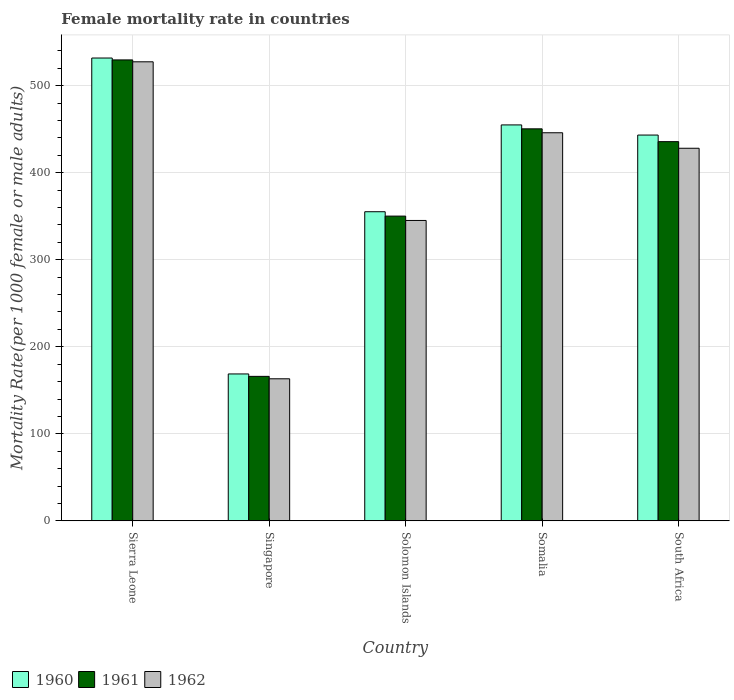How many bars are there on the 1st tick from the right?
Ensure brevity in your answer.  3. What is the label of the 3rd group of bars from the left?
Your answer should be compact. Solomon Islands. What is the female mortality rate in 1962 in Sierra Leone?
Make the answer very short. 527.53. Across all countries, what is the maximum female mortality rate in 1961?
Provide a short and direct response. 529.71. Across all countries, what is the minimum female mortality rate in 1961?
Offer a very short reply. 166.03. In which country was the female mortality rate in 1960 maximum?
Your response must be concise. Sierra Leone. In which country was the female mortality rate in 1961 minimum?
Provide a succinct answer. Singapore. What is the total female mortality rate in 1962 in the graph?
Keep it short and to the point. 1910.15. What is the difference between the female mortality rate in 1961 in Somalia and that in South Africa?
Provide a succinct answer. 14.73. What is the difference between the female mortality rate in 1961 in Sierra Leone and the female mortality rate in 1962 in Singapore?
Keep it short and to the point. 366.46. What is the average female mortality rate in 1962 per country?
Offer a terse response. 382.03. What is the difference between the female mortality rate of/in 1960 and female mortality rate of/in 1961 in Somalia?
Give a very brief answer. 4.5. What is the ratio of the female mortality rate in 1961 in Sierra Leone to that in Somalia?
Ensure brevity in your answer.  1.18. Is the difference between the female mortality rate in 1960 in Sierra Leone and Singapore greater than the difference between the female mortality rate in 1961 in Sierra Leone and Singapore?
Offer a very short reply. No. What is the difference between the highest and the second highest female mortality rate in 1962?
Offer a very short reply. -17.81. What is the difference between the highest and the lowest female mortality rate in 1960?
Make the answer very short. 363.07. Is the sum of the female mortality rate in 1962 in Solomon Islands and Somalia greater than the maximum female mortality rate in 1960 across all countries?
Provide a short and direct response. Yes. Is it the case that in every country, the sum of the female mortality rate in 1962 and female mortality rate in 1960 is greater than the female mortality rate in 1961?
Give a very brief answer. Yes. How many countries are there in the graph?
Make the answer very short. 5. What is the difference between two consecutive major ticks on the Y-axis?
Your answer should be compact. 100. Are the values on the major ticks of Y-axis written in scientific E-notation?
Keep it short and to the point. No. Does the graph contain any zero values?
Keep it short and to the point. No. Does the graph contain grids?
Keep it short and to the point. Yes. What is the title of the graph?
Offer a very short reply. Female mortality rate in countries. Does "1994" appear as one of the legend labels in the graph?
Your answer should be very brief. No. What is the label or title of the Y-axis?
Offer a terse response. Mortality Rate(per 1000 female or male adults). What is the Mortality Rate(per 1000 female or male adults) of 1960 in Sierra Leone?
Your answer should be very brief. 531.89. What is the Mortality Rate(per 1000 female or male adults) in 1961 in Sierra Leone?
Your response must be concise. 529.71. What is the Mortality Rate(per 1000 female or male adults) of 1962 in Sierra Leone?
Offer a terse response. 527.53. What is the Mortality Rate(per 1000 female or male adults) in 1960 in Singapore?
Keep it short and to the point. 168.82. What is the Mortality Rate(per 1000 female or male adults) of 1961 in Singapore?
Provide a succinct answer. 166.03. What is the Mortality Rate(per 1000 female or male adults) of 1962 in Singapore?
Make the answer very short. 163.25. What is the Mortality Rate(per 1000 female or male adults) of 1960 in Solomon Islands?
Provide a succinct answer. 355.23. What is the Mortality Rate(per 1000 female or male adults) in 1961 in Solomon Islands?
Your response must be concise. 350.21. What is the Mortality Rate(per 1000 female or male adults) of 1962 in Solomon Islands?
Offer a very short reply. 345.19. What is the Mortality Rate(per 1000 female or male adults) of 1960 in Somalia?
Offer a terse response. 455. What is the Mortality Rate(per 1000 female or male adults) of 1961 in Somalia?
Ensure brevity in your answer.  450.5. What is the Mortality Rate(per 1000 female or male adults) in 1962 in Somalia?
Your answer should be compact. 446. What is the Mortality Rate(per 1000 female or male adults) of 1960 in South Africa?
Provide a succinct answer. 443.35. What is the Mortality Rate(per 1000 female or male adults) in 1961 in South Africa?
Keep it short and to the point. 435.77. What is the Mortality Rate(per 1000 female or male adults) of 1962 in South Africa?
Provide a succinct answer. 428.18. Across all countries, what is the maximum Mortality Rate(per 1000 female or male adults) in 1960?
Give a very brief answer. 531.89. Across all countries, what is the maximum Mortality Rate(per 1000 female or male adults) in 1961?
Your response must be concise. 529.71. Across all countries, what is the maximum Mortality Rate(per 1000 female or male adults) in 1962?
Offer a very short reply. 527.53. Across all countries, what is the minimum Mortality Rate(per 1000 female or male adults) in 1960?
Give a very brief answer. 168.82. Across all countries, what is the minimum Mortality Rate(per 1000 female or male adults) in 1961?
Offer a terse response. 166.03. Across all countries, what is the minimum Mortality Rate(per 1000 female or male adults) in 1962?
Offer a terse response. 163.25. What is the total Mortality Rate(per 1000 female or male adults) of 1960 in the graph?
Your answer should be very brief. 1954.28. What is the total Mortality Rate(per 1000 female or male adults) in 1961 in the graph?
Your answer should be compact. 1932.21. What is the total Mortality Rate(per 1000 female or male adults) of 1962 in the graph?
Give a very brief answer. 1910.15. What is the difference between the Mortality Rate(per 1000 female or male adults) in 1960 in Sierra Leone and that in Singapore?
Provide a succinct answer. 363.07. What is the difference between the Mortality Rate(per 1000 female or male adults) in 1961 in Sierra Leone and that in Singapore?
Your response must be concise. 363.68. What is the difference between the Mortality Rate(per 1000 female or male adults) in 1962 in Sierra Leone and that in Singapore?
Your response must be concise. 364.29. What is the difference between the Mortality Rate(per 1000 female or male adults) in 1960 in Sierra Leone and that in Solomon Islands?
Make the answer very short. 176.66. What is the difference between the Mortality Rate(per 1000 female or male adults) in 1961 in Sierra Leone and that in Solomon Islands?
Ensure brevity in your answer.  179.5. What is the difference between the Mortality Rate(per 1000 female or male adults) of 1962 in Sierra Leone and that in Solomon Islands?
Offer a terse response. 182.34. What is the difference between the Mortality Rate(per 1000 female or male adults) in 1960 in Sierra Leone and that in Somalia?
Give a very brief answer. 76.89. What is the difference between the Mortality Rate(per 1000 female or male adults) of 1961 in Sierra Leone and that in Somalia?
Provide a short and direct response. 79.21. What is the difference between the Mortality Rate(per 1000 female or male adults) of 1962 in Sierra Leone and that in Somalia?
Give a very brief answer. 81.54. What is the difference between the Mortality Rate(per 1000 female or male adults) in 1960 in Sierra Leone and that in South Africa?
Keep it short and to the point. 88.54. What is the difference between the Mortality Rate(per 1000 female or male adults) of 1961 in Sierra Leone and that in South Africa?
Keep it short and to the point. 93.94. What is the difference between the Mortality Rate(per 1000 female or male adults) of 1962 in Sierra Leone and that in South Africa?
Provide a succinct answer. 99.35. What is the difference between the Mortality Rate(per 1000 female or male adults) of 1960 in Singapore and that in Solomon Islands?
Offer a very short reply. -186.41. What is the difference between the Mortality Rate(per 1000 female or male adults) of 1961 in Singapore and that in Solomon Islands?
Offer a terse response. -184.18. What is the difference between the Mortality Rate(per 1000 female or male adults) in 1962 in Singapore and that in Solomon Islands?
Your answer should be compact. -181.94. What is the difference between the Mortality Rate(per 1000 female or male adults) in 1960 in Singapore and that in Somalia?
Provide a succinct answer. -286.18. What is the difference between the Mortality Rate(per 1000 female or male adults) of 1961 in Singapore and that in Somalia?
Provide a succinct answer. -284.47. What is the difference between the Mortality Rate(per 1000 female or male adults) of 1962 in Singapore and that in Somalia?
Make the answer very short. -282.75. What is the difference between the Mortality Rate(per 1000 female or male adults) in 1960 in Singapore and that in South Africa?
Keep it short and to the point. -274.53. What is the difference between the Mortality Rate(per 1000 female or male adults) in 1961 in Singapore and that in South Africa?
Ensure brevity in your answer.  -269.74. What is the difference between the Mortality Rate(per 1000 female or male adults) in 1962 in Singapore and that in South Africa?
Your response must be concise. -264.94. What is the difference between the Mortality Rate(per 1000 female or male adults) of 1960 in Solomon Islands and that in Somalia?
Your answer should be compact. -99.77. What is the difference between the Mortality Rate(per 1000 female or male adults) of 1961 in Solomon Islands and that in Somalia?
Your response must be concise. -100.29. What is the difference between the Mortality Rate(per 1000 female or male adults) of 1962 in Solomon Islands and that in Somalia?
Give a very brief answer. -100.81. What is the difference between the Mortality Rate(per 1000 female or male adults) of 1960 in Solomon Islands and that in South Africa?
Offer a terse response. -88.12. What is the difference between the Mortality Rate(per 1000 female or male adults) in 1961 in Solomon Islands and that in South Africa?
Your response must be concise. -85.56. What is the difference between the Mortality Rate(per 1000 female or male adults) of 1962 in Solomon Islands and that in South Africa?
Your answer should be very brief. -82.99. What is the difference between the Mortality Rate(per 1000 female or male adults) of 1960 in Somalia and that in South Africa?
Ensure brevity in your answer.  11.65. What is the difference between the Mortality Rate(per 1000 female or male adults) of 1961 in Somalia and that in South Africa?
Give a very brief answer. 14.73. What is the difference between the Mortality Rate(per 1000 female or male adults) of 1962 in Somalia and that in South Africa?
Keep it short and to the point. 17.81. What is the difference between the Mortality Rate(per 1000 female or male adults) of 1960 in Sierra Leone and the Mortality Rate(per 1000 female or male adults) of 1961 in Singapore?
Give a very brief answer. 365.86. What is the difference between the Mortality Rate(per 1000 female or male adults) in 1960 in Sierra Leone and the Mortality Rate(per 1000 female or male adults) in 1962 in Singapore?
Provide a succinct answer. 368.64. What is the difference between the Mortality Rate(per 1000 female or male adults) in 1961 in Sierra Leone and the Mortality Rate(per 1000 female or male adults) in 1962 in Singapore?
Keep it short and to the point. 366.46. What is the difference between the Mortality Rate(per 1000 female or male adults) of 1960 in Sierra Leone and the Mortality Rate(per 1000 female or male adults) of 1961 in Solomon Islands?
Your answer should be compact. 181.68. What is the difference between the Mortality Rate(per 1000 female or male adults) of 1960 in Sierra Leone and the Mortality Rate(per 1000 female or male adults) of 1962 in Solomon Islands?
Offer a terse response. 186.7. What is the difference between the Mortality Rate(per 1000 female or male adults) of 1961 in Sierra Leone and the Mortality Rate(per 1000 female or male adults) of 1962 in Solomon Islands?
Give a very brief answer. 184.52. What is the difference between the Mortality Rate(per 1000 female or male adults) of 1960 in Sierra Leone and the Mortality Rate(per 1000 female or male adults) of 1961 in Somalia?
Your answer should be very brief. 81.39. What is the difference between the Mortality Rate(per 1000 female or male adults) of 1960 in Sierra Leone and the Mortality Rate(per 1000 female or male adults) of 1962 in Somalia?
Your response must be concise. 85.89. What is the difference between the Mortality Rate(per 1000 female or male adults) in 1961 in Sierra Leone and the Mortality Rate(per 1000 female or male adults) in 1962 in Somalia?
Keep it short and to the point. 83.71. What is the difference between the Mortality Rate(per 1000 female or male adults) in 1960 in Sierra Leone and the Mortality Rate(per 1000 female or male adults) in 1961 in South Africa?
Make the answer very short. 96.12. What is the difference between the Mortality Rate(per 1000 female or male adults) in 1960 in Sierra Leone and the Mortality Rate(per 1000 female or male adults) in 1962 in South Africa?
Your response must be concise. 103.7. What is the difference between the Mortality Rate(per 1000 female or male adults) in 1961 in Sierra Leone and the Mortality Rate(per 1000 female or male adults) in 1962 in South Africa?
Offer a terse response. 101.53. What is the difference between the Mortality Rate(per 1000 female or male adults) in 1960 in Singapore and the Mortality Rate(per 1000 female or male adults) in 1961 in Solomon Islands?
Make the answer very short. -181.39. What is the difference between the Mortality Rate(per 1000 female or male adults) in 1960 in Singapore and the Mortality Rate(per 1000 female or male adults) in 1962 in Solomon Islands?
Make the answer very short. -176.37. What is the difference between the Mortality Rate(per 1000 female or male adults) in 1961 in Singapore and the Mortality Rate(per 1000 female or male adults) in 1962 in Solomon Islands?
Provide a short and direct response. -179.16. What is the difference between the Mortality Rate(per 1000 female or male adults) in 1960 in Singapore and the Mortality Rate(per 1000 female or male adults) in 1961 in Somalia?
Ensure brevity in your answer.  -281.68. What is the difference between the Mortality Rate(per 1000 female or male adults) of 1960 in Singapore and the Mortality Rate(per 1000 female or male adults) of 1962 in Somalia?
Provide a succinct answer. -277.18. What is the difference between the Mortality Rate(per 1000 female or male adults) in 1961 in Singapore and the Mortality Rate(per 1000 female or male adults) in 1962 in Somalia?
Provide a succinct answer. -279.96. What is the difference between the Mortality Rate(per 1000 female or male adults) of 1960 in Singapore and the Mortality Rate(per 1000 female or male adults) of 1961 in South Africa?
Make the answer very short. -266.95. What is the difference between the Mortality Rate(per 1000 female or male adults) in 1960 in Singapore and the Mortality Rate(per 1000 female or male adults) in 1962 in South Africa?
Provide a succinct answer. -259.37. What is the difference between the Mortality Rate(per 1000 female or male adults) in 1961 in Singapore and the Mortality Rate(per 1000 female or male adults) in 1962 in South Africa?
Give a very brief answer. -262.15. What is the difference between the Mortality Rate(per 1000 female or male adults) in 1960 in Solomon Islands and the Mortality Rate(per 1000 female or male adults) in 1961 in Somalia?
Provide a short and direct response. -95.27. What is the difference between the Mortality Rate(per 1000 female or male adults) in 1960 in Solomon Islands and the Mortality Rate(per 1000 female or male adults) in 1962 in Somalia?
Ensure brevity in your answer.  -90.77. What is the difference between the Mortality Rate(per 1000 female or male adults) in 1961 in Solomon Islands and the Mortality Rate(per 1000 female or male adults) in 1962 in Somalia?
Your response must be concise. -95.79. What is the difference between the Mortality Rate(per 1000 female or male adults) of 1960 in Solomon Islands and the Mortality Rate(per 1000 female or male adults) of 1961 in South Africa?
Your response must be concise. -80.54. What is the difference between the Mortality Rate(per 1000 female or male adults) of 1960 in Solomon Islands and the Mortality Rate(per 1000 female or male adults) of 1962 in South Africa?
Give a very brief answer. -72.96. What is the difference between the Mortality Rate(per 1000 female or male adults) in 1961 in Solomon Islands and the Mortality Rate(per 1000 female or male adults) in 1962 in South Africa?
Make the answer very short. -77.97. What is the difference between the Mortality Rate(per 1000 female or male adults) of 1960 in Somalia and the Mortality Rate(per 1000 female or male adults) of 1961 in South Africa?
Give a very brief answer. 19.23. What is the difference between the Mortality Rate(per 1000 female or male adults) of 1960 in Somalia and the Mortality Rate(per 1000 female or male adults) of 1962 in South Africa?
Ensure brevity in your answer.  26.81. What is the difference between the Mortality Rate(per 1000 female or male adults) of 1961 in Somalia and the Mortality Rate(per 1000 female or male adults) of 1962 in South Africa?
Your answer should be very brief. 22.31. What is the average Mortality Rate(per 1000 female or male adults) of 1960 per country?
Your answer should be very brief. 390.86. What is the average Mortality Rate(per 1000 female or male adults) in 1961 per country?
Offer a very short reply. 386.44. What is the average Mortality Rate(per 1000 female or male adults) of 1962 per country?
Ensure brevity in your answer.  382.03. What is the difference between the Mortality Rate(per 1000 female or male adults) of 1960 and Mortality Rate(per 1000 female or male adults) of 1961 in Sierra Leone?
Provide a succinct answer. 2.18. What is the difference between the Mortality Rate(per 1000 female or male adults) in 1960 and Mortality Rate(per 1000 female or male adults) in 1962 in Sierra Leone?
Your response must be concise. 4.36. What is the difference between the Mortality Rate(per 1000 female or male adults) of 1961 and Mortality Rate(per 1000 female or male adults) of 1962 in Sierra Leone?
Your answer should be very brief. 2.18. What is the difference between the Mortality Rate(per 1000 female or male adults) in 1960 and Mortality Rate(per 1000 female or male adults) in 1961 in Singapore?
Keep it short and to the point. 2.78. What is the difference between the Mortality Rate(per 1000 female or male adults) of 1960 and Mortality Rate(per 1000 female or male adults) of 1962 in Singapore?
Offer a terse response. 5.57. What is the difference between the Mortality Rate(per 1000 female or male adults) in 1961 and Mortality Rate(per 1000 female or male adults) in 1962 in Singapore?
Make the answer very short. 2.78. What is the difference between the Mortality Rate(per 1000 female or male adults) in 1960 and Mortality Rate(per 1000 female or male adults) in 1961 in Solomon Islands?
Give a very brief answer. 5.02. What is the difference between the Mortality Rate(per 1000 female or male adults) in 1960 and Mortality Rate(per 1000 female or male adults) in 1962 in Solomon Islands?
Keep it short and to the point. 10.04. What is the difference between the Mortality Rate(per 1000 female or male adults) in 1961 and Mortality Rate(per 1000 female or male adults) in 1962 in Solomon Islands?
Your response must be concise. 5.02. What is the difference between the Mortality Rate(per 1000 female or male adults) in 1960 and Mortality Rate(per 1000 female or male adults) in 1961 in Somalia?
Your response must be concise. 4.5. What is the difference between the Mortality Rate(per 1000 female or male adults) in 1960 and Mortality Rate(per 1000 female or male adults) in 1962 in Somalia?
Your answer should be compact. 9. What is the difference between the Mortality Rate(per 1000 female or male adults) in 1961 and Mortality Rate(per 1000 female or male adults) in 1962 in Somalia?
Your response must be concise. 4.5. What is the difference between the Mortality Rate(per 1000 female or male adults) in 1960 and Mortality Rate(per 1000 female or male adults) in 1961 in South Africa?
Ensure brevity in your answer.  7.58. What is the difference between the Mortality Rate(per 1000 female or male adults) of 1960 and Mortality Rate(per 1000 female or male adults) of 1962 in South Africa?
Offer a very short reply. 15.16. What is the difference between the Mortality Rate(per 1000 female or male adults) in 1961 and Mortality Rate(per 1000 female or male adults) in 1962 in South Africa?
Your response must be concise. 7.58. What is the ratio of the Mortality Rate(per 1000 female or male adults) in 1960 in Sierra Leone to that in Singapore?
Offer a terse response. 3.15. What is the ratio of the Mortality Rate(per 1000 female or male adults) in 1961 in Sierra Leone to that in Singapore?
Provide a short and direct response. 3.19. What is the ratio of the Mortality Rate(per 1000 female or male adults) in 1962 in Sierra Leone to that in Singapore?
Make the answer very short. 3.23. What is the ratio of the Mortality Rate(per 1000 female or male adults) in 1960 in Sierra Leone to that in Solomon Islands?
Provide a succinct answer. 1.5. What is the ratio of the Mortality Rate(per 1000 female or male adults) in 1961 in Sierra Leone to that in Solomon Islands?
Keep it short and to the point. 1.51. What is the ratio of the Mortality Rate(per 1000 female or male adults) in 1962 in Sierra Leone to that in Solomon Islands?
Your answer should be compact. 1.53. What is the ratio of the Mortality Rate(per 1000 female or male adults) of 1960 in Sierra Leone to that in Somalia?
Your response must be concise. 1.17. What is the ratio of the Mortality Rate(per 1000 female or male adults) of 1961 in Sierra Leone to that in Somalia?
Make the answer very short. 1.18. What is the ratio of the Mortality Rate(per 1000 female or male adults) in 1962 in Sierra Leone to that in Somalia?
Your answer should be very brief. 1.18. What is the ratio of the Mortality Rate(per 1000 female or male adults) in 1960 in Sierra Leone to that in South Africa?
Your answer should be very brief. 1.2. What is the ratio of the Mortality Rate(per 1000 female or male adults) of 1961 in Sierra Leone to that in South Africa?
Offer a terse response. 1.22. What is the ratio of the Mortality Rate(per 1000 female or male adults) in 1962 in Sierra Leone to that in South Africa?
Provide a succinct answer. 1.23. What is the ratio of the Mortality Rate(per 1000 female or male adults) in 1960 in Singapore to that in Solomon Islands?
Offer a terse response. 0.48. What is the ratio of the Mortality Rate(per 1000 female or male adults) of 1961 in Singapore to that in Solomon Islands?
Offer a terse response. 0.47. What is the ratio of the Mortality Rate(per 1000 female or male adults) of 1962 in Singapore to that in Solomon Islands?
Provide a succinct answer. 0.47. What is the ratio of the Mortality Rate(per 1000 female or male adults) of 1960 in Singapore to that in Somalia?
Your answer should be compact. 0.37. What is the ratio of the Mortality Rate(per 1000 female or male adults) in 1961 in Singapore to that in Somalia?
Your answer should be very brief. 0.37. What is the ratio of the Mortality Rate(per 1000 female or male adults) in 1962 in Singapore to that in Somalia?
Give a very brief answer. 0.37. What is the ratio of the Mortality Rate(per 1000 female or male adults) in 1960 in Singapore to that in South Africa?
Offer a terse response. 0.38. What is the ratio of the Mortality Rate(per 1000 female or male adults) in 1961 in Singapore to that in South Africa?
Give a very brief answer. 0.38. What is the ratio of the Mortality Rate(per 1000 female or male adults) of 1962 in Singapore to that in South Africa?
Your answer should be compact. 0.38. What is the ratio of the Mortality Rate(per 1000 female or male adults) in 1960 in Solomon Islands to that in Somalia?
Give a very brief answer. 0.78. What is the ratio of the Mortality Rate(per 1000 female or male adults) of 1961 in Solomon Islands to that in Somalia?
Give a very brief answer. 0.78. What is the ratio of the Mortality Rate(per 1000 female or male adults) in 1962 in Solomon Islands to that in Somalia?
Your answer should be very brief. 0.77. What is the ratio of the Mortality Rate(per 1000 female or male adults) of 1960 in Solomon Islands to that in South Africa?
Ensure brevity in your answer.  0.8. What is the ratio of the Mortality Rate(per 1000 female or male adults) in 1961 in Solomon Islands to that in South Africa?
Offer a very short reply. 0.8. What is the ratio of the Mortality Rate(per 1000 female or male adults) in 1962 in Solomon Islands to that in South Africa?
Ensure brevity in your answer.  0.81. What is the ratio of the Mortality Rate(per 1000 female or male adults) of 1960 in Somalia to that in South Africa?
Give a very brief answer. 1.03. What is the ratio of the Mortality Rate(per 1000 female or male adults) of 1961 in Somalia to that in South Africa?
Ensure brevity in your answer.  1.03. What is the ratio of the Mortality Rate(per 1000 female or male adults) of 1962 in Somalia to that in South Africa?
Your answer should be very brief. 1.04. What is the difference between the highest and the second highest Mortality Rate(per 1000 female or male adults) in 1960?
Give a very brief answer. 76.89. What is the difference between the highest and the second highest Mortality Rate(per 1000 female or male adults) of 1961?
Offer a terse response. 79.21. What is the difference between the highest and the second highest Mortality Rate(per 1000 female or male adults) in 1962?
Make the answer very short. 81.54. What is the difference between the highest and the lowest Mortality Rate(per 1000 female or male adults) of 1960?
Provide a short and direct response. 363.07. What is the difference between the highest and the lowest Mortality Rate(per 1000 female or male adults) in 1961?
Your answer should be compact. 363.68. What is the difference between the highest and the lowest Mortality Rate(per 1000 female or male adults) in 1962?
Your answer should be compact. 364.29. 